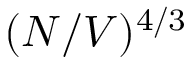<formula> <loc_0><loc_0><loc_500><loc_500>( N / V ) ^ { 4 / 3 }</formula> 